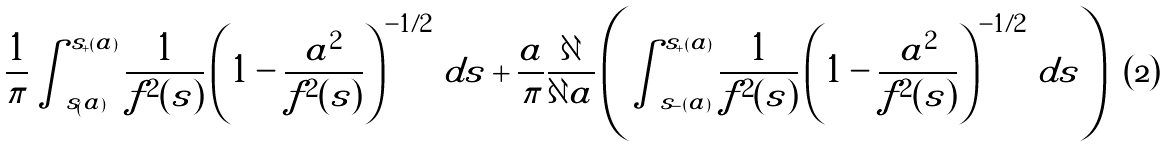Convert formula to latex. <formula><loc_0><loc_0><loc_500><loc_500>\frac { 1 } { \pi } \int _ { s _ { ( } a ) } ^ { s _ { + } ( a ) } \frac { 1 } { f ^ { 2 } ( s ) } \left ( 1 - \frac { a ^ { 2 } } { f ^ { 2 } ( s ) } \right ) ^ { - 1 / 2 } \, d s + \frac { a } { \pi } \frac { \partial } { \partial a } \left ( \int _ { s _ { - } ( a ) } ^ { s _ { + } ( a ) } \frac { 1 } { f ^ { 2 } ( s ) } \left ( 1 - \frac { a ^ { 2 } } { f ^ { 2 } ( s ) } \right ) ^ { - 1 / 2 } \, d s \right )</formula> 